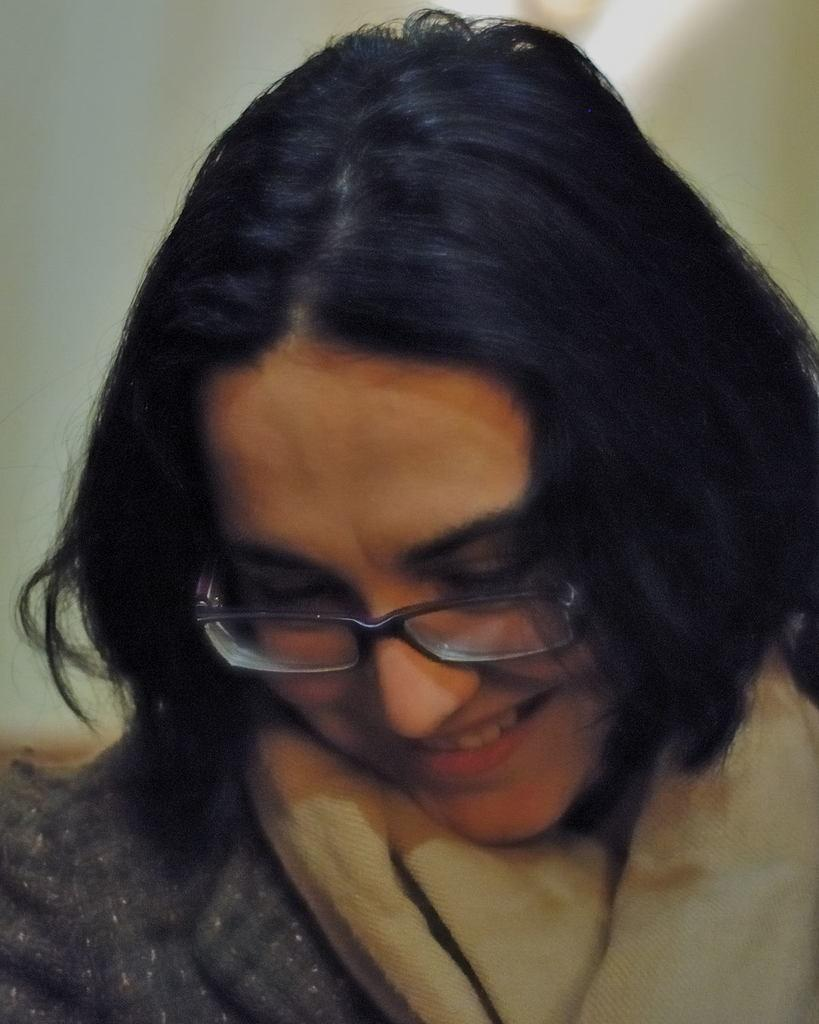Who is the main subject in the foreground of the image? There is a woman in the foreground of the image. What is the woman wearing in the image? The woman is wearing a grey jacket and has a scarf around her neck. What is the woman's facial expression in the image? The woman is smiling in the image. How would you describe the background of the image? The background of the image is blurred. What type of event is the woman representing in the image? There is no indication in the image that the woman is representing an event or has any representative role. 